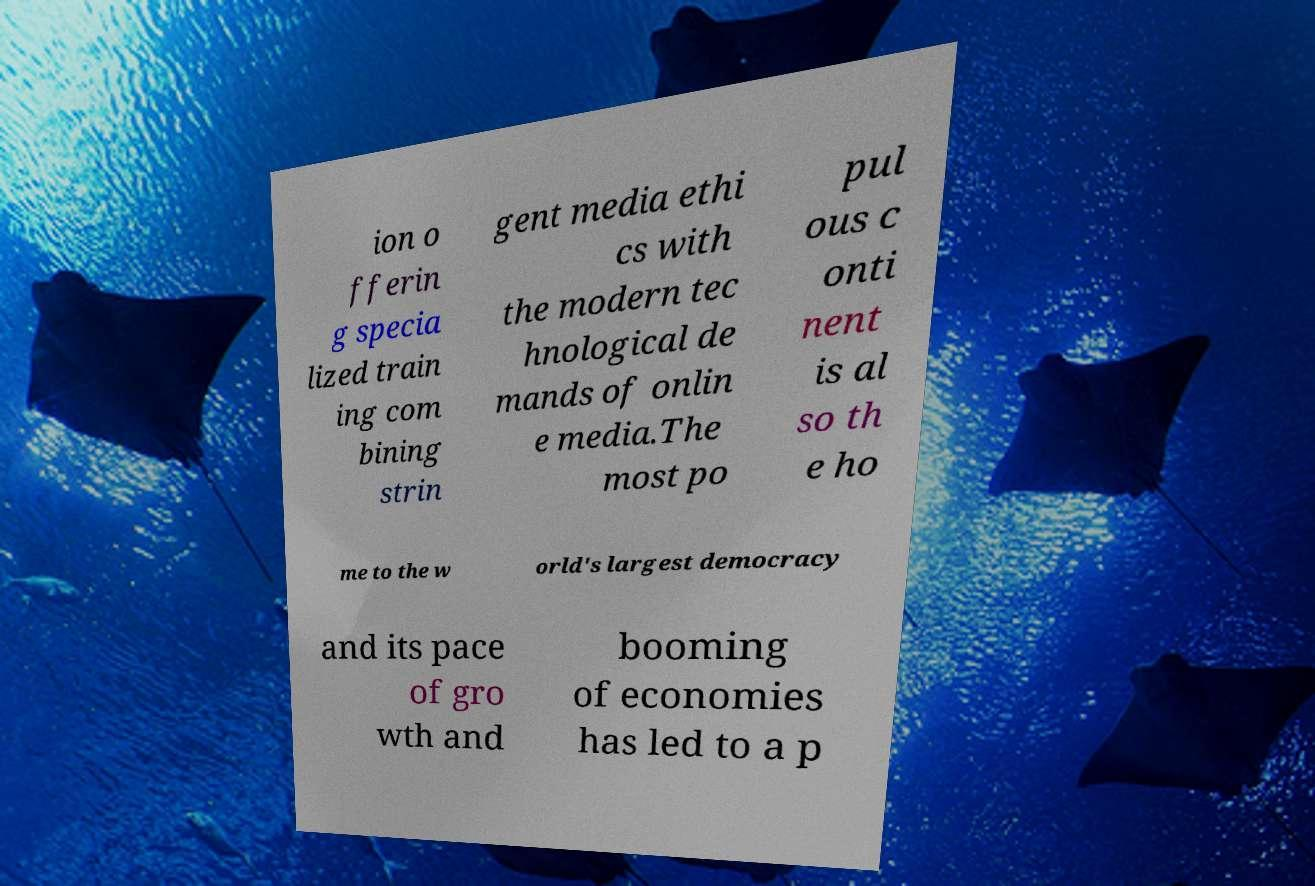For documentation purposes, I need the text within this image transcribed. Could you provide that? ion o fferin g specia lized train ing com bining strin gent media ethi cs with the modern tec hnological de mands of onlin e media.The most po pul ous c onti nent is al so th e ho me to the w orld's largest democracy and its pace of gro wth and booming of economies has led to a p 